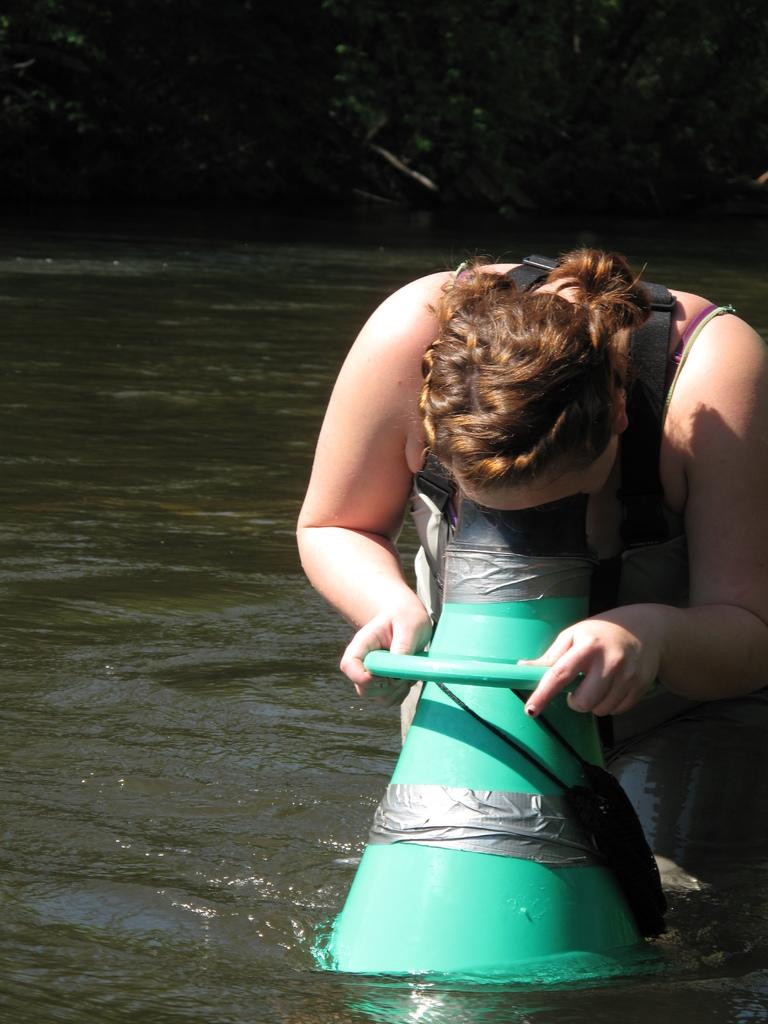What is the person in the image doing? The person is standing in water on the right side of the image. What is the person holding in the image? The person is holding an object. Can you describe the top part of the image? The top part of the image is blurry. What can be seen in the background of the image? There is water visible in the background of the image. What type of sign can be seen in the water near the person? There is no sign present in the image; it only features a person standing in water and holding an object. 